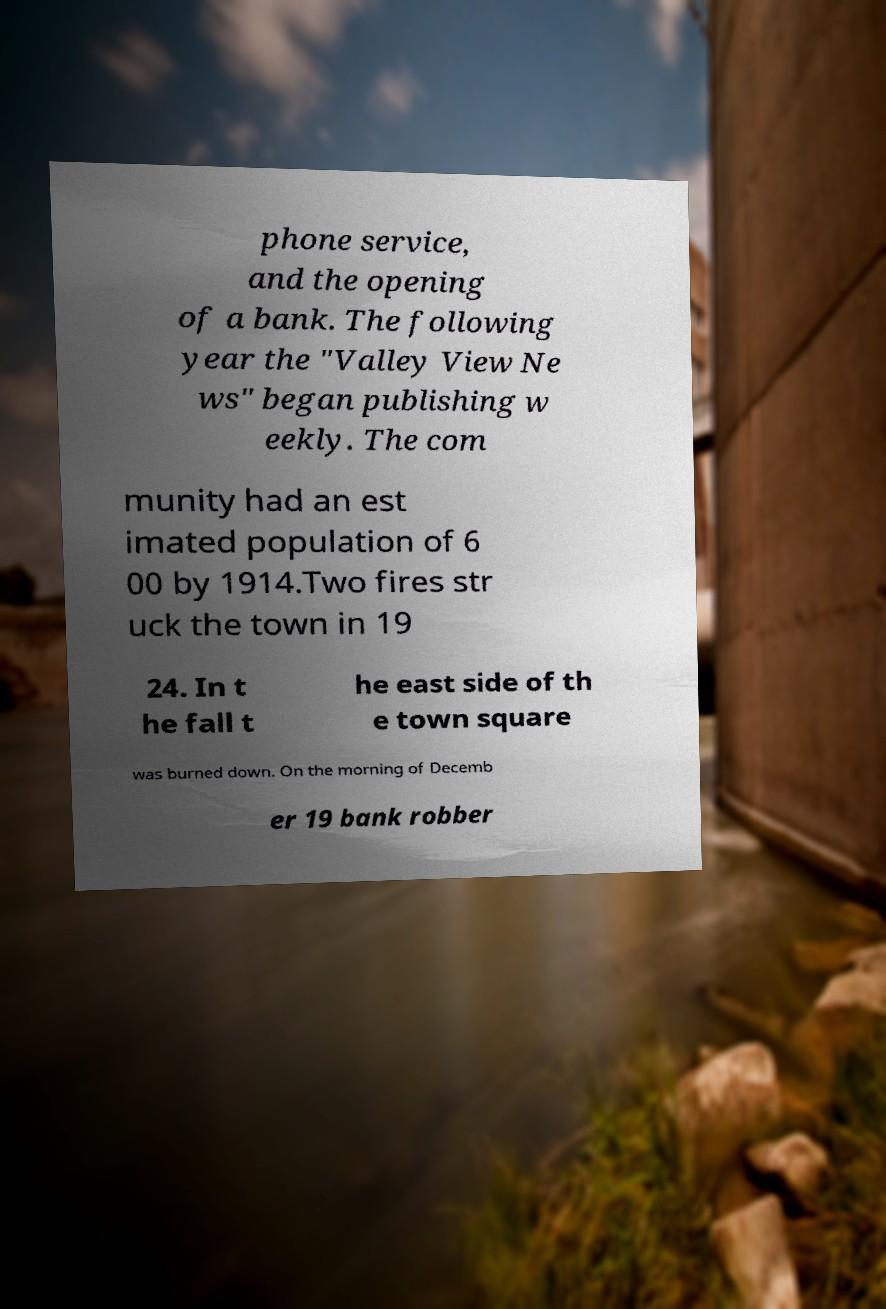Could you extract and type out the text from this image? phone service, and the opening of a bank. The following year the "Valley View Ne ws" began publishing w eekly. The com munity had an est imated population of 6 00 by 1914.Two fires str uck the town in 19 24. In t he fall t he east side of th e town square was burned down. On the morning of Decemb er 19 bank robber 